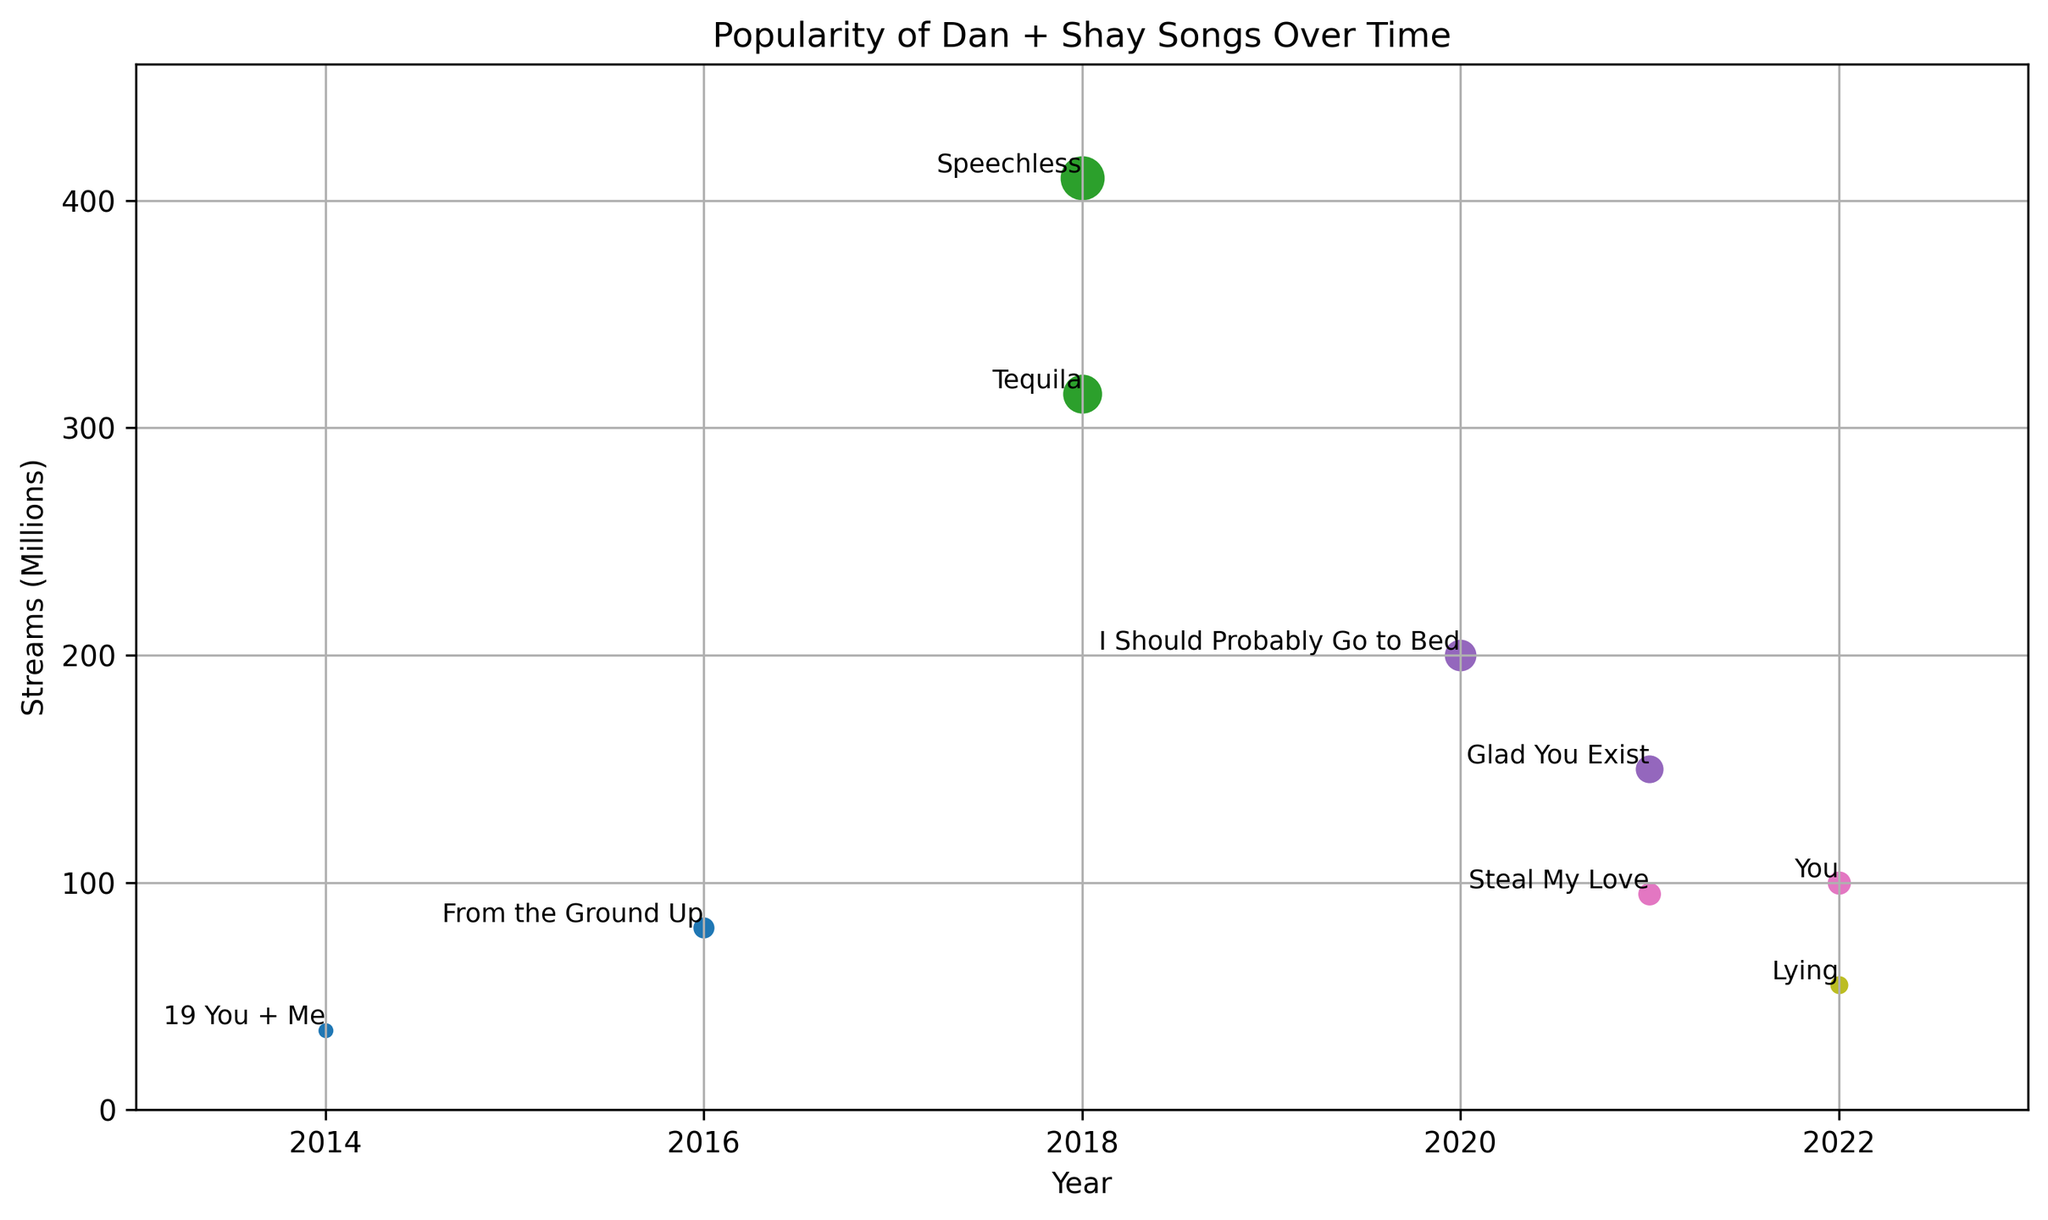Which song had the highest number of streams in 2018? In 2018, the figure shows two songs, "Tequila" and "Speechless." "Speechless" has higher streams than "Tequila."
Answer: Speechless How many total streams did Dan + Shay get in 2021 across all songs? The two songs in 2021 are "Glad You Exist" with 150 million streams and "Steal My Love" with 95 million streams. Adding these gives 150 + 95 = 245 million streams.
Answer: 245 Are there more songs listed from 2018 or 2022? There are two songs from 2018 ("Tequila" and "Speechless") and two from 2022 ("You" and "Lying"). Therefore, the counts for both years are equal.
Answer: Equal Between "From the Ground Up" and "Glad You Exist," which song has more streams? "From the Ground Up" has 80 million streams and "Glad You Exist" has 150 million streams. "Glad You Exist" has more streams than "From the Ground Up."
Answer: Glad You Exist Is the number of streams for "I Should Probably Go to Bed" higher than the combined streams for "You" and "Lying"? "I Should Probably Go to Bed" has 200 million streams, while the total for "You" (100) and "Lying" (55) is 100 + 55 = 155 million streams. 200 is greater than 155.
Answer: Yes How does the stream count for "Speechless" compare to "Tequila"? "Speechless" has 410 million streams, and "Tequila" has 315 million streams. "Speechless" has more streams than "Tequila."
Answer: Speechless has more What is the difference in streams between the highest and lowest streamed songs? The highest streamed song is "Speechless" with 410 million streams, and the lowest is "19 You + Me" with 35 million streams. The difference is 410 - 35 = 375 million streams.
Answer: 375 Which song from 2020 or later has the fewest streams? Songs from 2020 or later are "I Should Probably Go to Bed," "Glad You Exist," "Steal My Love," "You," and "Lying." "Lying" has the fewest streams at 55 million.
Answer: Lying What is the combined total for all the streams across the listed songs? Sum all the streams: 35 + 80 + 315 + 410 + 200 + 150 + 95 + 100 + 55 = 1440 million streams.
Answer: 1440 